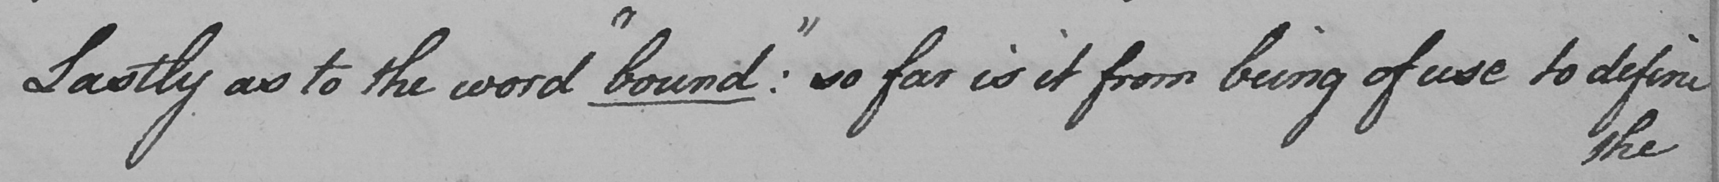Please transcribe the handwritten text in this image. Lastly as to the word  " bound "  :  so far is it from being of use to define 